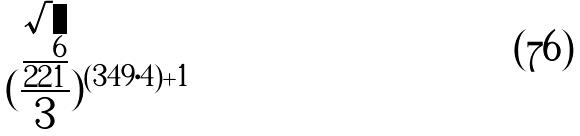<formula> <loc_0><loc_0><loc_500><loc_500>( \frac { \frac { \sqrt { 6 } } { 2 2 1 } } { 3 } ) ^ { ( 3 4 9 \cdot 4 ) + 1 }</formula> 